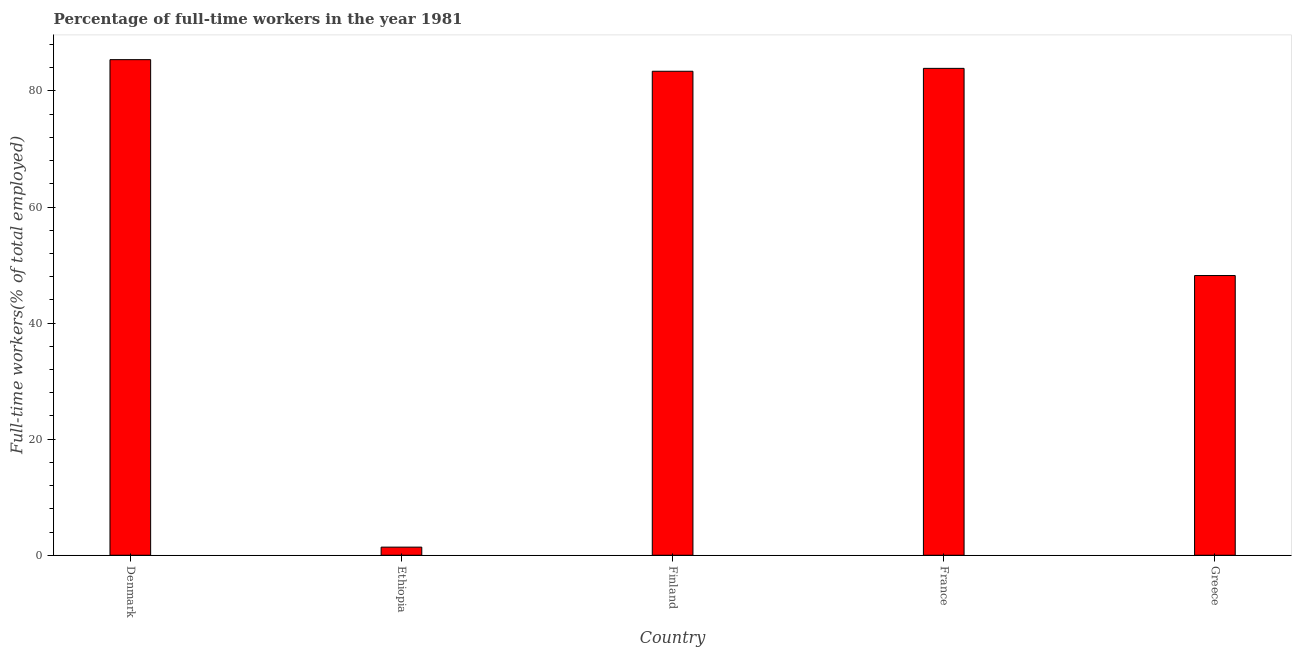Does the graph contain grids?
Your response must be concise. No. What is the title of the graph?
Your response must be concise. Percentage of full-time workers in the year 1981. What is the label or title of the X-axis?
Make the answer very short. Country. What is the label or title of the Y-axis?
Make the answer very short. Full-time workers(% of total employed). What is the percentage of full-time workers in France?
Offer a very short reply. 83.9. Across all countries, what is the maximum percentage of full-time workers?
Provide a succinct answer. 85.4. Across all countries, what is the minimum percentage of full-time workers?
Your response must be concise. 1.4. In which country was the percentage of full-time workers minimum?
Your response must be concise. Ethiopia. What is the sum of the percentage of full-time workers?
Provide a short and direct response. 302.3. What is the difference between the percentage of full-time workers in Finland and Greece?
Offer a very short reply. 35.2. What is the average percentage of full-time workers per country?
Keep it short and to the point. 60.46. What is the median percentage of full-time workers?
Offer a very short reply. 83.4. What is the ratio of the percentage of full-time workers in Ethiopia to that in Finland?
Offer a very short reply. 0.02. What is the difference between the highest and the second highest percentage of full-time workers?
Provide a succinct answer. 1.5. In how many countries, is the percentage of full-time workers greater than the average percentage of full-time workers taken over all countries?
Your answer should be compact. 3. Are all the bars in the graph horizontal?
Offer a very short reply. No. What is the difference between two consecutive major ticks on the Y-axis?
Your answer should be very brief. 20. Are the values on the major ticks of Y-axis written in scientific E-notation?
Your answer should be very brief. No. What is the Full-time workers(% of total employed) in Denmark?
Give a very brief answer. 85.4. What is the Full-time workers(% of total employed) in Ethiopia?
Your response must be concise. 1.4. What is the Full-time workers(% of total employed) of Finland?
Give a very brief answer. 83.4. What is the Full-time workers(% of total employed) in France?
Provide a short and direct response. 83.9. What is the Full-time workers(% of total employed) of Greece?
Ensure brevity in your answer.  48.2. What is the difference between the Full-time workers(% of total employed) in Denmark and Ethiopia?
Keep it short and to the point. 84. What is the difference between the Full-time workers(% of total employed) in Denmark and Finland?
Keep it short and to the point. 2. What is the difference between the Full-time workers(% of total employed) in Denmark and Greece?
Your answer should be very brief. 37.2. What is the difference between the Full-time workers(% of total employed) in Ethiopia and Finland?
Provide a short and direct response. -82. What is the difference between the Full-time workers(% of total employed) in Ethiopia and France?
Ensure brevity in your answer.  -82.5. What is the difference between the Full-time workers(% of total employed) in Ethiopia and Greece?
Ensure brevity in your answer.  -46.8. What is the difference between the Full-time workers(% of total employed) in Finland and Greece?
Make the answer very short. 35.2. What is the difference between the Full-time workers(% of total employed) in France and Greece?
Your answer should be very brief. 35.7. What is the ratio of the Full-time workers(% of total employed) in Denmark to that in Ethiopia?
Your response must be concise. 61. What is the ratio of the Full-time workers(% of total employed) in Denmark to that in Finland?
Your response must be concise. 1.02. What is the ratio of the Full-time workers(% of total employed) in Denmark to that in France?
Offer a very short reply. 1.02. What is the ratio of the Full-time workers(% of total employed) in Denmark to that in Greece?
Ensure brevity in your answer.  1.77. What is the ratio of the Full-time workers(% of total employed) in Ethiopia to that in Finland?
Offer a terse response. 0.02. What is the ratio of the Full-time workers(% of total employed) in Ethiopia to that in France?
Make the answer very short. 0.02. What is the ratio of the Full-time workers(% of total employed) in Ethiopia to that in Greece?
Your answer should be very brief. 0.03. What is the ratio of the Full-time workers(% of total employed) in Finland to that in Greece?
Make the answer very short. 1.73. What is the ratio of the Full-time workers(% of total employed) in France to that in Greece?
Offer a terse response. 1.74. 